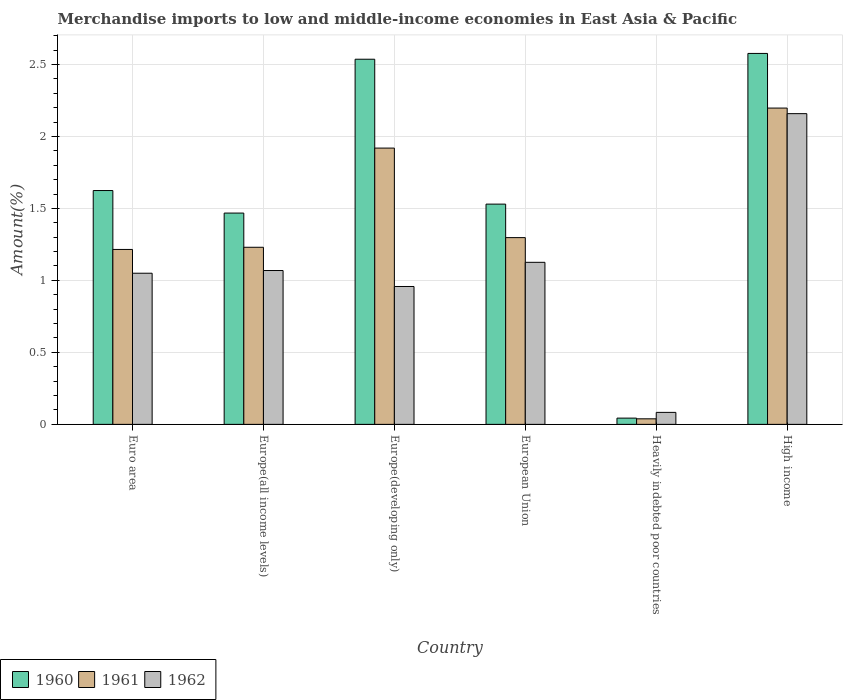How many different coloured bars are there?
Your answer should be compact. 3. How many bars are there on the 4th tick from the left?
Give a very brief answer. 3. How many bars are there on the 4th tick from the right?
Give a very brief answer. 3. What is the label of the 5th group of bars from the left?
Your answer should be very brief. Heavily indebted poor countries. What is the percentage of amount earned from merchandise imports in 1960 in Europe(developing only)?
Your answer should be very brief. 2.54. Across all countries, what is the maximum percentage of amount earned from merchandise imports in 1962?
Your answer should be very brief. 2.16. Across all countries, what is the minimum percentage of amount earned from merchandise imports in 1961?
Provide a succinct answer. 0.04. In which country was the percentage of amount earned from merchandise imports in 1961 maximum?
Keep it short and to the point. High income. In which country was the percentage of amount earned from merchandise imports in 1961 minimum?
Provide a short and direct response. Heavily indebted poor countries. What is the total percentage of amount earned from merchandise imports in 1960 in the graph?
Keep it short and to the point. 9.78. What is the difference between the percentage of amount earned from merchandise imports in 1960 in Euro area and that in Heavily indebted poor countries?
Your response must be concise. 1.58. What is the difference between the percentage of amount earned from merchandise imports in 1962 in Europe(developing only) and the percentage of amount earned from merchandise imports in 1961 in Heavily indebted poor countries?
Give a very brief answer. 0.92. What is the average percentage of amount earned from merchandise imports in 1961 per country?
Your answer should be compact. 1.32. What is the difference between the percentage of amount earned from merchandise imports of/in 1961 and percentage of amount earned from merchandise imports of/in 1960 in Euro area?
Provide a succinct answer. -0.41. In how many countries, is the percentage of amount earned from merchandise imports in 1962 greater than 1.8 %?
Offer a very short reply. 1. What is the ratio of the percentage of amount earned from merchandise imports in 1962 in European Union to that in High income?
Offer a terse response. 0.52. Is the difference between the percentage of amount earned from merchandise imports in 1961 in Europe(developing only) and European Union greater than the difference between the percentage of amount earned from merchandise imports in 1960 in Europe(developing only) and European Union?
Your answer should be compact. No. What is the difference between the highest and the second highest percentage of amount earned from merchandise imports in 1961?
Provide a succinct answer. -0.28. What is the difference between the highest and the lowest percentage of amount earned from merchandise imports in 1962?
Offer a terse response. 2.07. In how many countries, is the percentage of amount earned from merchandise imports in 1962 greater than the average percentage of amount earned from merchandise imports in 1962 taken over all countries?
Your answer should be compact. 2. What does the 3rd bar from the left in Heavily indebted poor countries represents?
Your answer should be very brief. 1962. How many bars are there?
Your response must be concise. 18. What is the difference between two consecutive major ticks on the Y-axis?
Your response must be concise. 0.5. Are the values on the major ticks of Y-axis written in scientific E-notation?
Offer a very short reply. No. Does the graph contain any zero values?
Your response must be concise. No. Does the graph contain grids?
Provide a short and direct response. Yes. What is the title of the graph?
Offer a very short reply. Merchandise imports to low and middle-income economies in East Asia & Pacific. What is the label or title of the Y-axis?
Your answer should be compact. Amount(%). What is the Amount(%) of 1960 in Euro area?
Offer a terse response. 1.62. What is the Amount(%) in 1961 in Euro area?
Your response must be concise. 1.21. What is the Amount(%) in 1962 in Euro area?
Provide a short and direct response. 1.05. What is the Amount(%) of 1960 in Europe(all income levels)?
Offer a very short reply. 1.47. What is the Amount(%) of 1961 in Europe(all income levels)?
Make the answer very short. 1.23. What is the Amount(%) of 1962 in Europe(all income levels)?
Offer a terse response. 1.07. What is the Amount(%) of 1960 in Europe(developing only)?
Your answer should be very brief. 2.54. What is the Amount(%) in 1961 in Europe(developing only)?
Ensure brevity in your answer.  1.92. What is the Amount(%) of 1962 in Europe(developing only)?
Provide a short and direct response. 0.96. What is the Amount(%) in 1960 in European Union?
Offer a very short reply. 1.53. What is the Amount(%) of 1961 in European Union?
Provide a succinct answer. 1.3. What is the Amount(%) in 1962 in European Union?
Give a very brief answer. 1.13. What is the Amount(%) in 1960 in Heavily indebted poor countries?
Provide a short and direct response. 0.04. What is the Amount(%) in 1961 in Heavily indebted poor countries?
Your answer should be compact. 0.04. What is the Amount(%) in 1962 in Heavily indebted poor countries?
Your response must be concise. 0.08. What is the Amount(%) of 1960 in High income?
Offer a very short reply. 2.58. What is the Amount(%) in 1961 in High income?
Your answer should be compact. 2.2. What is the Amount(%) in 1962 in High income?
Your response must be concise. 2.16. Across all countries, what is the maximum Amount(%) in 1960?
Provide a short and direct response. 2.58. Across all countries, what is the maximum Amount(%) of 1961?
Offer a very short reply. 2.2. Across all countries, what is the maximum Amount(%) in 1962?
Offer a very short reply. 2.16. Across all countries, what is the minimum Amount(%) in 1960?
Your answer should be compact. 0.04. Across all countries, what is the minimum Amount(%) in 1961?
Your response must be concise. 0.04. Across all countries, what is the minimum Amount(%) of 1962?
Offer a terse response. 0.08. What is the total Amount(%) of 1960 in the graph?
Your answer should be very brief. 9.78. What is the total Amount(%) of 1961 in the graph?
Your answer should be compact. 7.9. What is the total Amount(%) in 1962 in the graph?
Your response must be concise. 6.44. What is the difference between the Amount(%) in 1960 in Euro area and that in Europe(all income levels)?
Keep it short and to the point. 0.16. What is the difference between the Amount(%) in 1961 in Euro area and that in Europe(all income levels)?
Make the answer very short. -0.01. What is the difference between the Amount(%) of 1962 in Euro area and that in Europe(all income levels)?
Keep it short and to the point. -0.02. What is the difference between the Amount(%) of 1960 in Euro area and that in Europe(developing only)?
Keep it short and to the point. -0.91. What is the difference between the Amount(%) of 1961 in Euro area and that in Europe(developing only)?
Keep it short and to the point. -0.7. What is the difference between the Amount(%) of 1962 in Euro area and that in Europe(developing only)?
Provide a short and direct response. 0.09. What is the difference between the Amount(%) of 1960 in Euro area and that in European Union?
Offer a terse response. 0.09. What is the difference between the Amount(%) of 1961 in Euro area and that in European Union?
Provide a succinct answer. -0.08. What is the difference between the Amount(%) in 1962 in Euro area and that in European Union?
Your response must be concise. -0.08. What is the difference between the Amount(%) in 1960 in Euro area and that in Heavily indebted poor countries?
Provide a succinct answer. 1.58. What is the difference between the Amount(%) of 1961 in Euro area and that in Heavily indebted poor countries?
Your answer should be compact. 1.18. What is the difference between the Amount(%) of 1962 in Euro area and that in Heavily indebted poor countries?
Provide a short and direct response. 0.97. What is the difference between the Amount(%) in 1960 in Euro area and that in High income?
Offer a very short reply. -0.95. What is the difference between the Amount(%) of 1961 in Euro area and that in High income?
Provide a succinct answer. -0.98. What is the difference between the Amount(%) of 1962 in Euro area and that in High income?
Your answer should be compact. -1.11. What is the difference between the Amount(%) in 1960 in Europe(all income levels) and that in Europe(developing only)?
Your response must be concise. -1.07. What is the difference between the Amount(%) of 1961 in Europe(all income levels) and that in Europe(developing only)?
Offer a very short reply. -0.69. What is the difference between the Amount(%) in 1962 in Europe(all income levels) and that in Europe(developing only)?
Provide a short and direct response. 0.11. What is the difference between the Amount(%) of 1960 in Europe(all income levels) and that in European Union?
Your answer should be compact. -0.06. What is the difference between the Amount(%) of 1961 in Europe(all income levels) and that in European Union?
Offer a very short reply. -0.07. What is the difference between the Amount(%) in 1962 in Europe(all income levels) and that in European Union?
Provide a short and direct response. -0.06. What is the difference between the Amount(%) in 1960 in Europe(all income levels) and that in Heavily indebted poor countries?
Offer a terse response. 1.42. What is the difference between the Amount(%) in 1961 in Europe(all income levels) and that in Heavily indebted poor countries?
Offer a terse response. 1.19. What is the difference between the Amount(%) of 1960 in Europe(all income levels) and that in High income?
Your response must be concise. -1.11. What is the difference between the Amount(%) in 1961 in Europe(all income levels) and that in High income?
Make the answer very short. -0.97. What is the difference between the Amount(%) in 1962 in Europe(all income levels) and that in High income?
Offer a terse response. -1.09. What is the difference between the Amount(%) of 1960 in Europe(developing only) and that in European Union?
Offer a very short reply. 1.01. What is the difference between the Amount(%) of 1961 in Europe(developing only) and that in European Union?
Offer a terse response. 0.62. What is the difference between the Amount(%) of 1962 in Europe(developing only) and that in European Union?
Give a very brief answer. -0.17. What is the difference between the Amount(%) in 1960 in Europe(developing only) and that in Heavily indebted poor countries?
Provide a short and direct response. 2.49. What is the difference between the Amount(%) in 1961 in Europe(developing only) and that in Heavily indebted poor countries?
Make the answer very short. 1.88. What is the difference between the Amount(%) of 1962 in Europe(developing only) and that in Heavily indebted poor countries?
Give a very brief answer. 0.87. What is the difference between the Amount(%) in 1960 in Europe(developing only) and that in High income?
Make the answer very short. -0.04. What is the difference between the Amount(%) in 1961 in Europe(developing only) and that in High income?
Your response must be concise. -0.28. What is the difference between the Amount(%) of 1962 in Europe(developing only) and that in High income?
Give a very brief answer. -1.2. What is the difference between the Amount(%) of 1960 in European Union and that in Heavily indebted poor countries?
Keep it short and to the point. 1.49. What is the difference between the Amount(%) of 1961 in European Union and that in Heavily indebted poor countries?
Offer a very short reply. 1.26. What is the difference between the Amount(%) of 1962 in European Union and that in Heavily indebted poor countries?
Offer a very short reply. 1.04. What is the difference between the Amount(%) in 1960 in European Union and that in High income?
Make the answer very short. -1.05. What is the difference between the Amount(%) of 1961 in European Union and that in High income?
Your answer should be compact. -0.9. What is the difference between the Amount(%) of 1962 in European Union and that in High income?
Offer a very short reply. -1.03. What is the difference between the Amount(%) in 1960 in Heavily indebted poor countries and that in High income?
Offer a terse response. -2.53. What is the difference between the Amount(%) of 1961 in Heavily indebted poor countries and that in High income?
Keep it short and to the point. -2.16. What is the difference between the Amount(%) in 1962 in Heavily indebted poor countries and that in High income?
Offer a terse response. -2.07. What is the difference between the Amount(%) of 1960 in Euro area and the Amount(%) of 1961 in Europe(all income levels)?
Offer a terse response. 0.39. What is the difference between the Amount(%) of 1960 in Euro area and the Amount(%) of 1962 in Europe(all income levels)?
Your response must be concise. 0.56. What is the difference between the Amount(%) of 1961 in Euro area and the Amount(%) of 1962 in Europe(all income levels)?
Offer a very short reply. 0.15. What is the difference between the Amount(%) in 1960 in Euro area and the Amount(%) in 1961 in Europe(developing only)?
Keep it short and to the point. -0.29. What is the difference between the Amount(%) in 1960 in Euro area and the Amount(%) in 1962 in Europe(developing only)?
Offer a very short reply. 0.67. What is the difference between the Amount(%) in 1961 in Euro area and the Amount(%) in 1962 in Europe(developing only)?
Ensure brevity in your answer.  0.26. What is the difference between the Amount(%) of 1960 in Euro area and the Amount(%) of 1961 in European Union?
Provide a short and direct response. 0.33. What is the difference between the Amount(%) in 1960 in Euro area and the Amount(%) in 1962 in European Union?
Make the answer very short. 0.5. What is the difference between the Amount(%) of 1961 in Euro area and the Amount(%) of 1962 in European Union?
Make the answer very short. 0.09. What is the difference between the Amount(%) in 1960 in Euro area and the Amount(%) in 1961 in Heavily indebted poor countries?
Make the answer very short. 1.59. What is the difference between the Amount(%) of 1960 in Euro area and the Amount(%) of 1962 in Heavily indebted poor countries?
Your answer should be compact. 1.54. What is the difference between the Amount(%) of 1961 in Euro area and the Amount(%) of 1962 in Heavily indebted poor countries?
Offer a very short reply. 1.13. What is the difference between the Amount(%) of 1960 in Euro area and the Amount(%) of 1961 in High income?
Provide a succinct answer. -0.57. What is the difference between the Amount(%) in 1960 in Euro area and the Amount(%) in 1962 in High income?
Provide a short and direct response. -0.53. What is the difference between the Amount(%) of 1961 in Euro area and the Amount(%) of 1962 in High income?
Make the answer very short. -0.94. What is the difference between the Amount(%) of 1960 in Europe(all income levels) and the Amount(%) of 1961 in Europe(developing only)?
Keep it short and to the point. -0.45. What is the difference between the Amount(%) of 1960 in Europe(all income levels) and the Amount(%) of 1962 in Europe(developing only)?
Your response must be concise. 0.51. What is the difference between the Amount(%) of 1961 in Europe(all income levels) and the Amount(%) of 1962 in Europe(developing only)?
Your answer should be compact. 0.27. What is the difference between the Amount(%) of 1960 in Europe(all income levels) and the Amount(%) of 1961 in European Union?
Your answer should be very brief. 0.17. What is the difference between the Amount(%) of 1960 in Europe(all income levels) and the Amount(%) of 1962 in European Union?
Your answer should be compact. 0.34. What is the difference between the Amount(%) in 1961 in Europe(all income levels) and the Amount(%) in 1962 in European Union?
Make the answer very short. 0.1. What is the difference between the Amount(%) of 1960 in Europe(all income levels) and the Amount(%) of 1961 in Heavily indebted poor countries?
Keep it short and to the point. 1.43. What is the difference between the Amount(%) of 1960 in Europe(all income levels) and the Amount(%) of 1962 in Heavily indebted poor countries?
Keep it short and to the point. 1.38. What is the difference between the Amount(%) of 1961 in Europe(all income levels) and the Amount(%) of 1962 in Heavily indebted poor countries?
Give a very brief answer. 1.15. What is the difference between the Amount(%) of 1960 in Europe(all income levels) and the Amount(%) of 1961 in High income?
Offer a terse response. -0.73. What is the difference between the Amount(%) in 1960 in Europe(all income levels) and the Amount(%) in 1962 in High income?
Keep it short and to the point. -0.69. What is the difference between the Amount(%) in 1961 in Europe(all income levels) and the Amount(%) in 1962 in High income?
Provide a succinct answer. -0.93. What is the difference between the Amount(%) in 1960 in Europe(developing only) and the Amount(%) in 1961 in European Union?
Keep it short and to the point. 1.24. What is the difference between the Amount(%) of 1960 in Europe(developing only) and the Amount(%) of 1962 in European Union?
Give a very brief answer. 1.41. What is the difference between the Amount(%) in 1961 in Europe(developing only) and the Amount(%) in 1962 in European Union?
Provide a short and direct response. 0.79. What is the difference between the Amount(%) in 1960 in Europe(developing only) and the Amount(%) in 1961 in Heavily indebted poor countries?
Make the answer very short. 2.5. What is the difference between the Amount(%) of 1960 in Europe(developing only) and the Amount(%) of 1962 in Heavily indebted poor countries?
Offer a terse response. 2.45. What is the difference between the Amount(%) of 1961 in Europe(developing only) and the Amount(%) of 1962 in Heavily indebted poor countries?
Make the answer very short. 1.84. What is the difference between the Amount(%) in 1960 in Europe(developing only) and the Amount(%) in 1961 in High income?
Your answer should be very brief. 0.34. What is the difference between the Amount(%) in 1960 in Europe(developing only) and the Amount(%) in 1962 in High income?
Make the answer very short. 0.38. What is the difference between the Amount(%) of 1961 in Europe(developing only) and the Amount(%) of 1962 in High income?
Make the answer very short. -0.24. What is the difference between the Amount(%) of 1960 in European Union and the Amount(%) of 1961 in Heavily indebted poor countries?
Make the answer very short. 1.49. What is the difference between the Amount(%) of 1960 in European Union and the Amount(%) of 1962 in Heavily indebted poor countries?
Provide a short and direct response. 1.45. What is the difference between the Amount(%) in 1961 in European Union and the Amount(%) in 1962 in Heavily indebted poor countries?
Your answer should be very brief. 1.21. What is the difference between the Amount(%) in 1960 in European Union and the Amount(%) in 1961 in High income?
Provide a short and direct response. -0.67. What is the difference between the Amount(%) of 1960 in European Union and the Amount(%) of 1962 in High income?
Make the answer very short. -0.63. What is the difference between the Amount(%) in 1961 in European Union and the Amount(%) in 1962 in High income?
Make the answer very short. -0.86. What is the difference between the Amount(%) in 1960 in Heavily indebted poor countries and the Amount(%) in 1961 in High income?
Ensure brevity in your answer.  -2.15. What is the difference between the Amount(%) in 1960 in Heavily indebted poor countries and the Amount(%) in 1962 in High income?
Provide a succinct answer. -2.11. What is the difference between the Amount(%) of 1961 in Heavily indebted poor countries and the Amount(%) of 1962 in High income?
Ensure brevity in your answer.  -2.12. What is the average Amount(%) in 1960 per country?
Make the answer very short. 1.63. What is the average Amount(%) of 1961 per country?
Your response must be concise. 1.32. What is the average Amount(%) in 1962 per country?
Your answer should be very brief. 1.07. What is the difference between the Amount(%) of 1960 and Amount(%) of 1961 in Euro area?
Ensure brevity in your answer.  0.41. What is the difference between the Amount(%) in 1960 and Amount(%) in 1962 in Euro area?
Your response must be concise. 0.57. What is the difference between the Amount(%) of 1961 and Amount(%) of 1962 in Euro area?
Provide a short and direct response. 0.17. What is the difference between the Amount(%) of 1960 and Amount(%) of 1961 in Europe(all income levels)?
Offer a terse response. 0.24. What is the difference between the Amount(%) of 1960 and Amount(%) of 1962 in Europe(all income levels)?
Your answer should be compact. 0.4. What is the difference between the Amount(%) in 1961 and Amount(%) in 1962 in Europe(all income levels)?
Give a very brief answer. 0.16. What is the difference between the Amount(%) of 1960 and Amount(%) of 1961 in Europe(developing only)?
Offer a very short reply. 0.62. What is the difference between the Amount(%) in 1960 and Amount(%) in 1962 in Europe(developing only)?
Your answer should be very brief. 1.58. What is the difference between the Amount(%) in 1961 and Amount(%) in 1962 in Europe(developing only)?
Offer a very short reply. 0.96. What is the difference between the Amount(%) in 1960 and Amount(%) in 1961 in European Union?
Your response must be concise. 0.23. What is the difference between the Amount(%) in 1960 and Amount(%) in 1962 in European Union?
Keep it short and to the point. 0.4. What is the difference between the Amount(%) in 1961 and Amount(%) in 1962 in European Union?
Give a very brief answer. 0.17. What is the difference between the Amount(%) of 1960 and Amount(%) of 1961 in Heavily indebted poor countries?
Your answer should be compact. 0. What is the difference between the Amount(%) in 1960 and Amount(%) in 1962 in Heavily indebted poor countries?
Give a very brief answer. -0.04. What is the difference between the Amount(%) in 1961 and Amount(%) in 1962 in Heavily indebted poor countries?
Ensure brevity in your answer.  -0.04. What is the difference between the Amount(%) of 1960 and Amount(%) of 1961 in High income?
Ensure brevity in your answer.  0.38. What is the difference between the Amount(%) in 1960 and Amount(%) in 1962 in High income?
Provide a short and direct response. 0.42. What is the difference between the Amount(%) of 1961 and Amount(%) of 1962 in High income?
Give a very brief answer. 0.04. What is the ratio of the Amount(%) in 1960 in Euro area to that in Europe(all income levels)?
Ensure brevity in your answer.  1.11. What is the ratio of the Amount(%) in 1961 in Euro area to that in Europe(all income levels)?
Your response must be concise. 0.99. What is the ratio of the Amount(%) in 1962 in Euro area to that in Europe(all income levels)?
Your answer should be compact. 0.98. What is the ratio of the Amount(%) in 1960 in Euro area to that in Europe(developing only)?
Your response must be concise. 0.64. What is the ratio of the Amount(%) of 1961 in Euro area to that in Europe(developing only)?
Ensure brevity in your answer.  0.63. What is the ratio of the Amount(%) in 1962 in Euro area to that in Europe(developing only)?
Offer a terse response. 1.1. What is the ratio of the Amount(%) of 1960 in Euro area to that in European Union?
Provide a short and direct response. 1.06. What is the ratio of the Amount(%) of 1961 in Euro area to that in European Union?
Ensure brevity in your answer.  0.94. What is the ratio of the Amount(%) in 1962 in Euro area to that in European Union?
Keep it short and to the point. 0.93. What is the ratio of the Amount(%) in 1960 in Euro area to that in Heavily indebted poor countries?
Keep it short and to the point. 37.4. What is the ratio of the Amount(%) in 1961 in Euro area to that in Heavily indebted poor countries?
Give a very brief answer. 31.47. What is the ratio of the Amount(%) of 1962 in Euro area to that in Heavily indebted poor countries?
Provide a succinct answer. 12.6. What is the ratio of the Amount(%) of 1960 in Euro area to that in High income?
Provide a short and direct response. 0.63. What is the ratio of the Amount(%) of 1961 in Euro area to that in High income?
Keep it short and to the point. 0.55. What is the ratio of the Amount(%) in 1962 in Euro area to that in High income?
Your response must be concise. 0.49. What is the ratio of the Amount(%) of 1960 in Europe(all income levels) to that in Europe(developing only)?
Provide a succinct answer. 0.58. What is the ratio of the Amount(%) of 1961 in Europe(all income levels) to that in Europe(developing only)?
Your answer should be compact. 0.64. What is the ratio of the Amount(%) in 1962 in Europe(all income levels) to that in Europe(developing only)?
Provide a short and direct response. 1.12. What is the ratio of the Amount(%) of 1960 in Europe(all income levels) to that in European Union?
Your answer should be compact. 0.96. What is the ratio of the Amount(%) of 1961 in Europe(all income levels) to that in European Union?
Keep it short and to the point. 0.95. What is the ratio of the Amount(%) in 1962 in Europe(all income levels) to that in European Union?
Keep it short and to the point. 0.95. What is the ratio of the Amount(%) of 1960 in Europe(all income levels) to that in Heavily indebted poor countries?
Your answer should be very brief. 33.79. What is the ratio of the Amount(%) of 1961 in Europe(all income levels) to that in Heavily indebted poor countries?
Provide a short and direct response. 31.86. What is the ratio of the Amount(%) in 1962 in Europe(all income levels) to that in Heavily indebted poor countries?
Provide a succinct answer. 12.83. What is the ratio of the Amount(%) in 1960 in Europe(all income levels) to that in High income?
Provide a succinct answer. 0.57. What is the ratio of the Amount(%) of 1961 in Europe(all income levels) to that in High income?
Provide a succinct answer. 0.56. What is the ratio of the Amount(%) of 1962 in Europe(all income levels) to that in High income?
Make the answer very short. 0.5. What is the ratio of the Amount(%) in 1960 in Europe(developing only) to that in European Union?
Offer a very short reply. 1.66. What is the ratio of the Amount(%) of 1961 in Europe(developing only) to that in European Union?
Your answer should be compact. 1.48. What is the ratio of the Amount(%) of 1962 in Europe(developing only) to that in European Union?
Your answer should be very brief. 0.85. What is the ratio of the Amount(%) of 1960 in Europe(developing only) to that in Heavily indebted poor countries?
Your answer should be compact. 58.4. What is the ratio of the Amount(%) of 1961 in Europe(developing only) to that in Heavily indebted poor countries?
Provide a succinct answer. 49.7. What is the ratio of the Amount(%) in 1962 in Europe(developing only) to that in Heavily indebted poor countries?
Offer a very short reply. 11.5. What is the ratio of the Amount(%) in 1960 in Europe(developing only) to that in High income?
Ensure brevity in your answer.  0.98. What is the ratio of the Amount(%) in 1961 in Europe(developing only) to that in High income?
Keep it short and to the point. 0.87. What is the ratio of the Amount(%) of 1962 in Europe(developing only) to that in High income?
Provide a short and direct response. 0.44. What is the ratio of the Amount(%) of 1960 in European Union to that in Heavily indebted poor countries?
Provide a short and direct response. 35.23. What is the ratio of the Amount(%) in 1961 in European Union to that in Heavily indebted poor countries?
Your response must be concise. 33.59. What is the ratio of the Amount(%) in 1962 in European Union to that in Heavily indebted poor countries?
Make the answer very short. 13.51. What is the ratio of the Amount(%) of 1960 in European Union to that in High income?
Your response must be concise. 0.59. What is the ratio of the Amount(%) of 1961 in European Union to that in High income?
Provide a short and direct response. 0.59. What is the ratio of the Amount(%) in 1962 in European Union to that in High income?
Provide a succinct answer. 0.52. What is the ratio of the Amount(%) in 1960 in Heavily indebted poor countries to that in High income?
Your response must be concise. 0.02. What is the ratio of the Amount(%) of 1961 in Heavily indebted poor countries to that in High income?
Make the answer very short. 0.02. What is the ratio of the Amount(%) in 1962 in Heavily indebted poor countries to that in High income?
Make the answer very short. 0.04. What is the difference between the highest and the second highest Amount(%) in 1960?
Ensure brevity in your answer.  0.04. What is the difference between the highest and the second highest Amount(%) in 1961?
Keep it short and to the point. 0.28. What is the difference between the highest and the second highest Amount(%) in 1962?
Provide a succinct answer. 1.03. What is the difference between the highest and the lowest Amount(%) of 1960?
Make the answer very short. 2.53. What is the difference between the highest and the lowest Amount(%) in 1961?
Make the answer very short. 2.16. What is the difference between the highest and the lowest Amount(%) in 1962?
Your answer should be compact. 2.07. 